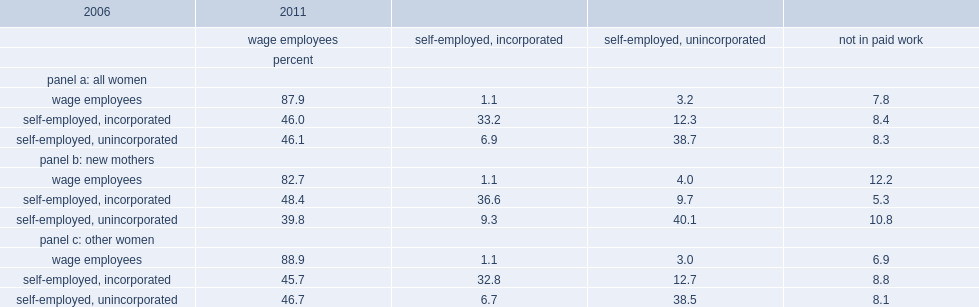What is ther percentage of women who had been wage earners in 2006 remained wage earners in 2011? 87.9. What is the percentage of women who were wage employees in 2006 made a transition to self-employment in 2011? 4.3. What is the percentage of all women who had been unincorporated self-employed in 2006 became wage empolyees in 2011? 46.1. What is the percentage of other women who were wage employees in 2006 remained in wage employment in 2011? 88.9. What is the percentage of new mothers who were wage employees in 2006 remained in wage employment in 2011? 82.7. 